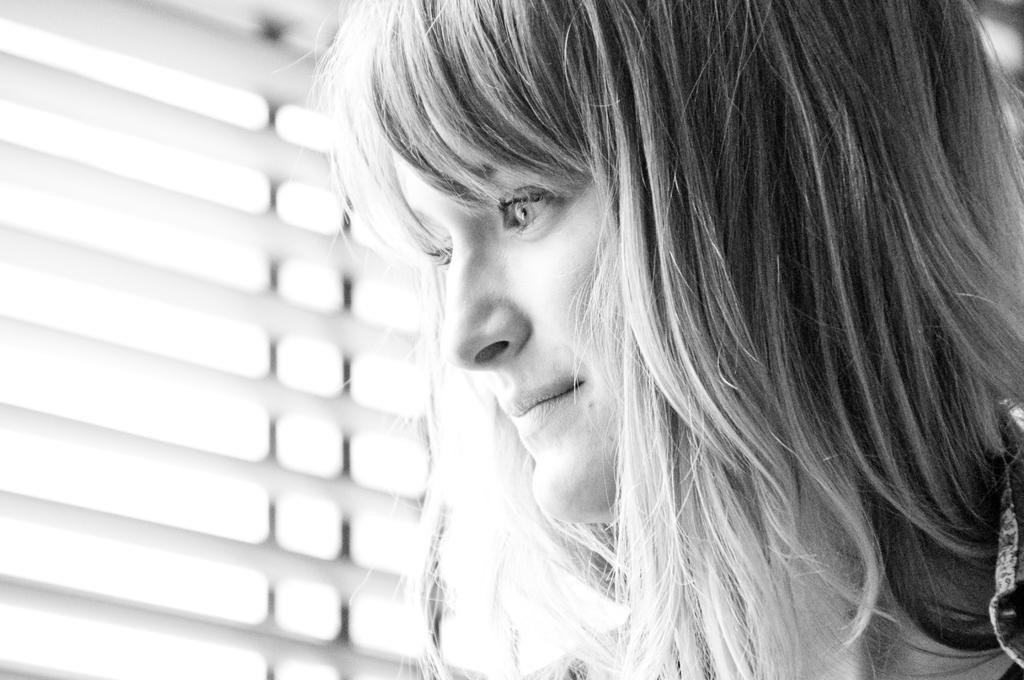Who is the main subject in the image? There is a woman in the image. Where is the woman located in the image? The woman is in the front of the image. What can be seen in the background of the image? There is a window in the background of the image. What type of orange is the woman holding in the image? There is no orange present in the image; the woman is the main subject. 